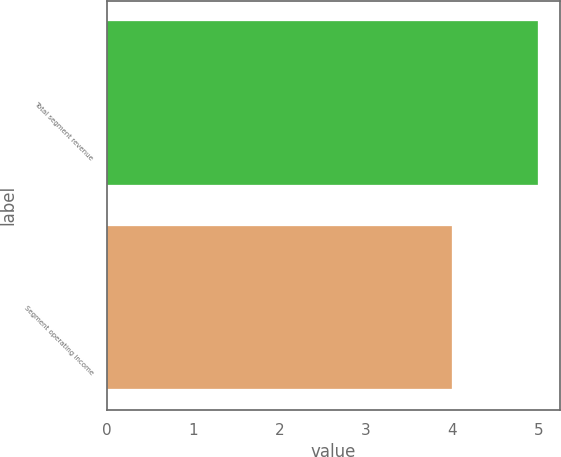Convert chart. <chart><loc_0><loc_0><loc_500><loc_500><bar_chart><fcel>Total segment revenue<fcel>Segment operating income<nl><fcel>5<fcel>4<nl></chart> 